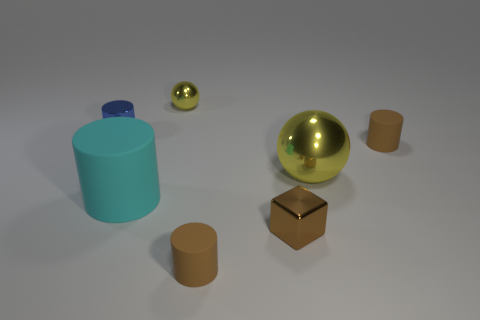Does the brown block have the same size as the shiny thing that is left of the tiny yellow sphere?
Give a very brief answer. Yes. What material is the cyan cylinder that is in front of the small thing that is left of the cyan matte cylinder?
Offer a very short reply. Rubber. Is the number of matte cylinders that are to the right of the small metal cube the same as the number of red matte blocks?
Provide a short and direct response. No. How big is the object that is both behind the big yellow metal sphere and on the right side of the cube?
Ensure brevity in your answer.  Small. What is the color of the small rubber object that is on the right side of the cylinder that is in front of the brown block?
Keep it short and to the point. Brown. How many red objects are small spheres or small rubber cylinders?
Keep it short and to the point. 0. The cylinder that is both behind the cyan object and in front of the tiny blue object is what color?
Provide a succinct answer. Brown. How many large objects are balls or red metallic things?
Ensure brevity in your answer.  1. There is a blue object that is the same shape as the large cyan thing; what size is it?
Your answer should be compact. Small. The cyan thing is what shape?
Offer a very short reply. Cylinder. 